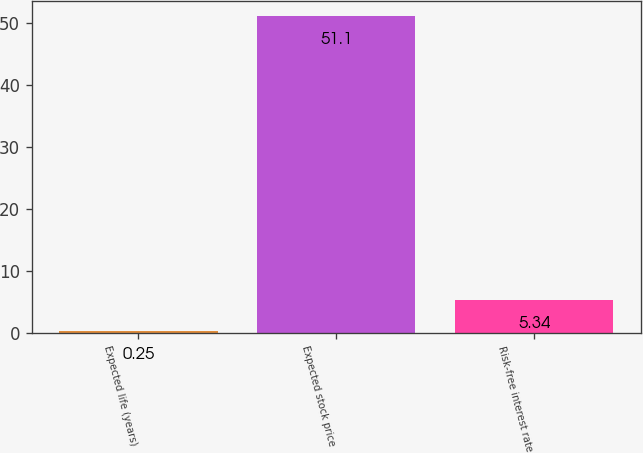<chart> <loc_0><loc_0><loc_500><loc_500><bar_chart><fcel>Expected life (years)<fcel>Expected stock price<fcel>Risk-free interest rate<nl><fcel>0.25<fcel>51.1<fcel>5.34<nl></chart> 